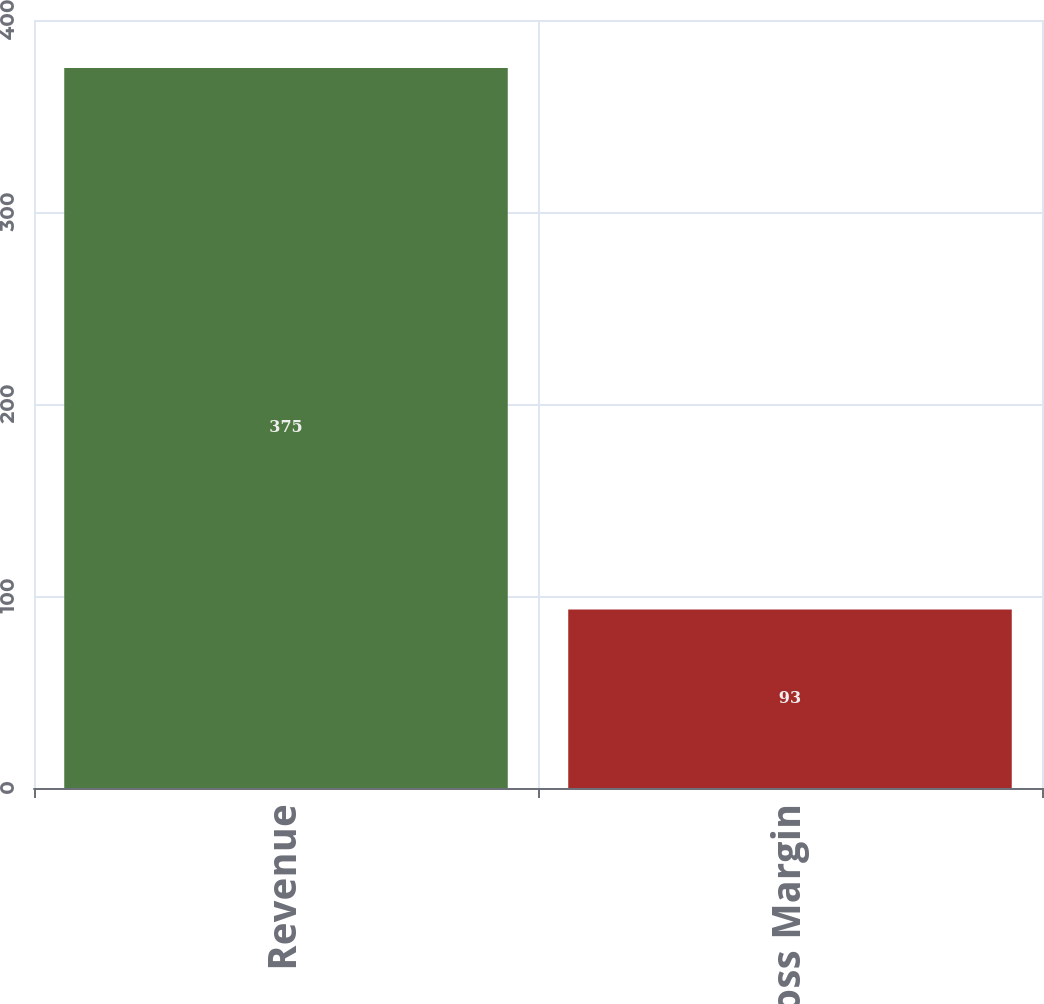Convert chart to OTSL. <chart><loc_0><loc_0><loc_500><loc_500><bar_chart><fcel>Revenue<fcel>Gross Margin<nl><fcel>375<fcel>93<nl></chart> 